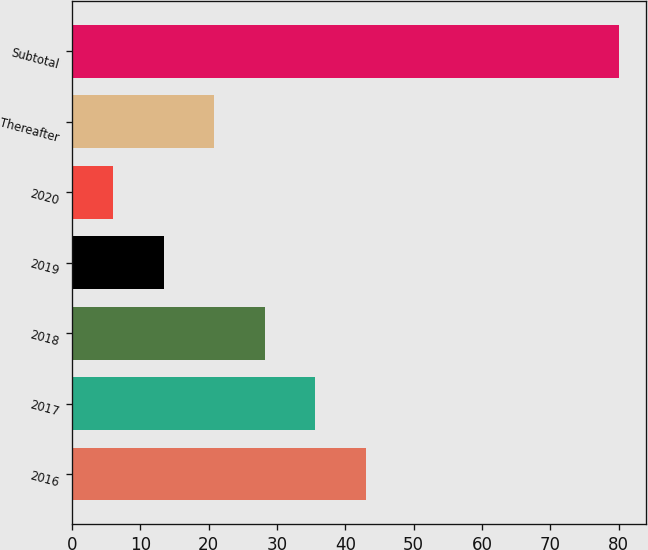<chart> <loc_0><loc_0><loc_500><loc_500><bar_chart><fcel>2016<fcel>2017<fcel>2018<fcel>2019<fcel>2020<fcel>Thereafter<fcel>Subtotal<nl><fcel>43<fcel>35.6<fcel>28.2<fcel>13.4<fcel>6<fcel>20.8<fcel>80<nl></chart> 